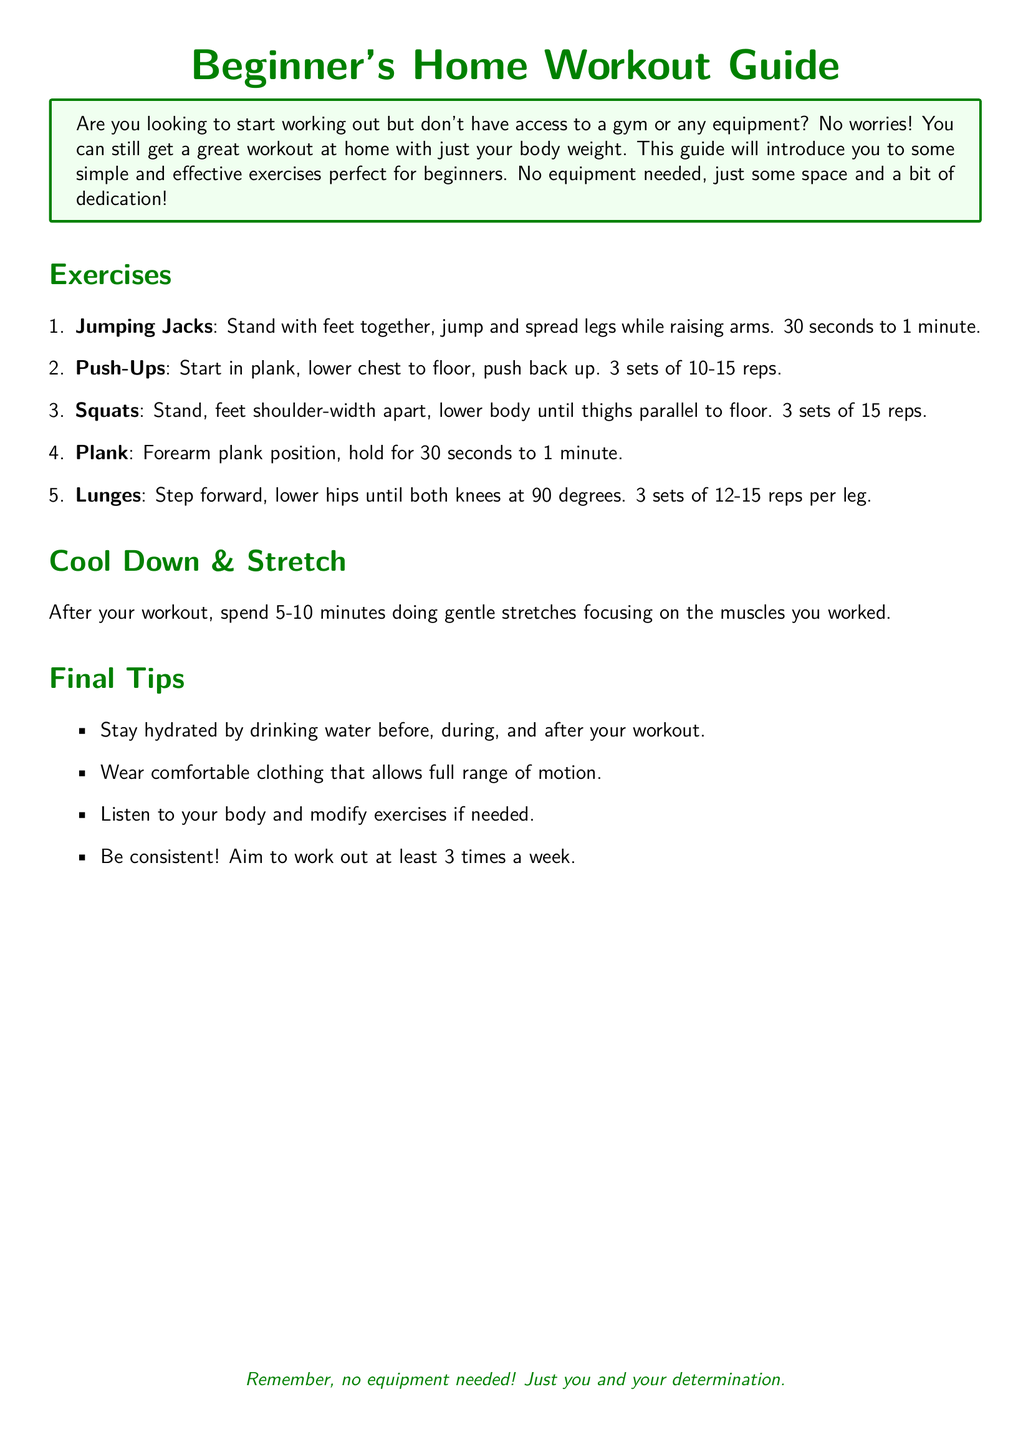What is the title of the document? The title of the document appears prominently at the beginning and is indicated as "Beginner's Home Workout Guide."
Answer: Beginner's Home Workout Guide How long should you hold the plank? The document specifies to hold the plank for 30 seconds to 1 minute.
Answer: 30 seconds to 1 minute How many sets of push-ups are recommended? The document states to perform 3 sets of push-ups.
Answer: 3 sets What exercise involves stepping forward? The document describes lunges as the exercise that involves stepping forward.
Answer: Lunges What is recommended to wear during the workout? The final tips section suggests wearing comfortable clothing that allows full range of motion.
Answer: Comfortable clothing What is the duration of the cool down and stretch? The document recommends spending 5-10 minutes on cool down and stretching.
Answer: 5-10 minutes How often should you aim to work out? The document advises to aim for at least 3 times a week for workouts.
Answer: At least 3 times a week What is required for the workout? The introduction mentions that no equipment is needed, just your body weight.
Answer: No equipment 